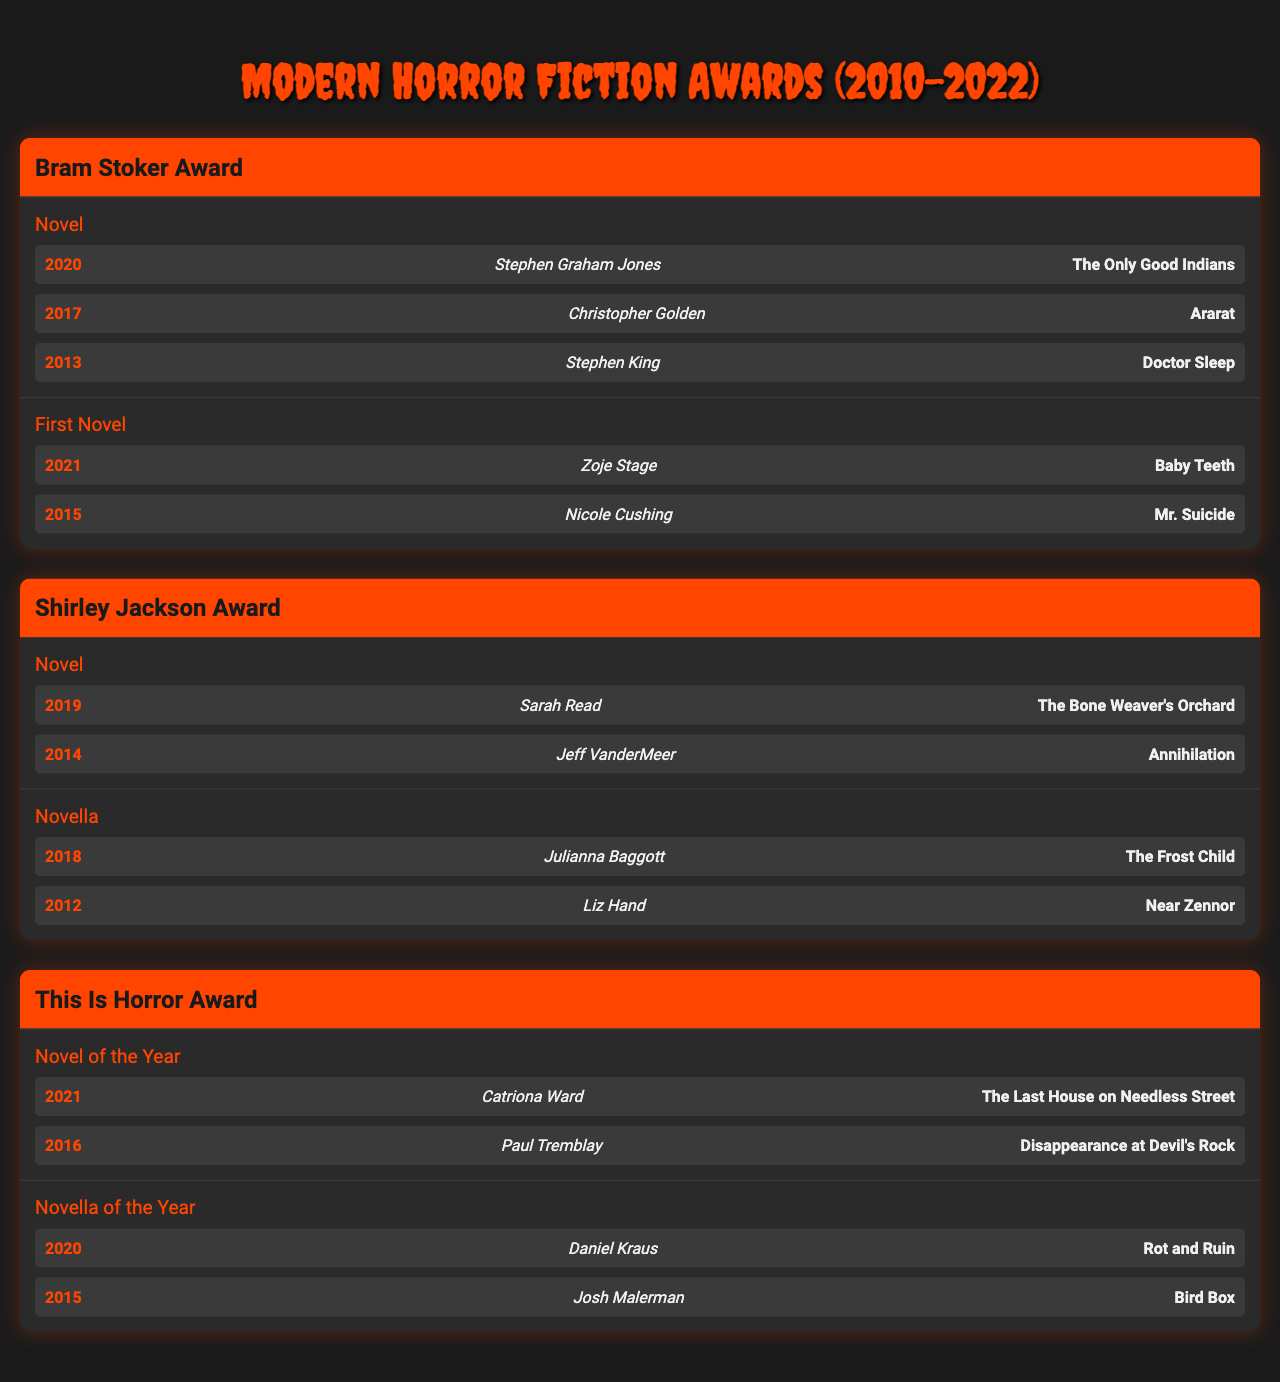What is the title of the Bram Stoker Award winner for Novel in 2020? The table lists the notable winners for the Bram Stoker Award under the Novel category. In 2020, the entry shows that Stephen Graham Jones won for the title "The Only Good Indians."
Answer: The Only Good Indians Who won the Shirley Jackson Award for Novella in 2012? Looking at the Shirley Jackson Award section, under the Novella category, it states that Liz Hand won in 2012 for "Near Zennor."
Answer: Liz Hand How many different categories are listed under the This Is Horror Award? The This Is Horror Award has two categories mentioned: Novel of the Year and Novella of the Year. Therefore, there are a total of 2 categories.
Answer: 2 Which award did Sarah Read win and for which title? The table shows that Sarah Read won the Shirley Jackson Award for Novel in 2019 with the title "The Bone Weaver's Orchard."
Answer: Shirley Jackson Award, The Bone Weaver's Orchard Was Stephen King a winner in 2019? Checking the winners in 2019, Stephen King is not listed as a winner for any award in that year according to the table.
Answer: No What is the total number of winners for the First Novel category in the Bram Stoker Award? The First Novel category lists 2 notable winners: Zoje Stage in 2021 and Nicole Cushing in 2015. Thus, there are a total of 2 winners in this category.
Answer: 2 Who received the This Is Horror Award for Novel of the Year in 2021? According to the This Is Horror Award section, Catriona Ward won for "The Last House on Needless Street" in 2021.
Answer: Catriona Ward Which author won for the category of Novella in the This Is Horror Award and in what year? The table provides the winners for the Novella of the Year under the This Is Horror Award, showing Daniel Kraus as the winner in 2020 for "Rot and Ruin."
Answer: Daniel Kraus, 2020 What is the difference in years between the wins of Stephen King and Christopher Golden in the Bram Stoker Award for Novel? Stephen King won in 2013, and Christopher Golden won in 2017. The difference in years is 2017 - 2013, which equals 4 years.
Answer: 4 years Name one author who has won the Bram Stoker Award for Novel more than once. According to the table, it shows that Stephen King has won the Bram Stoker Award for Novel in different years but only appears once as a notable winner in this data set. Therefore, he does not meet the criteria based on the visible data.
Answer: None 